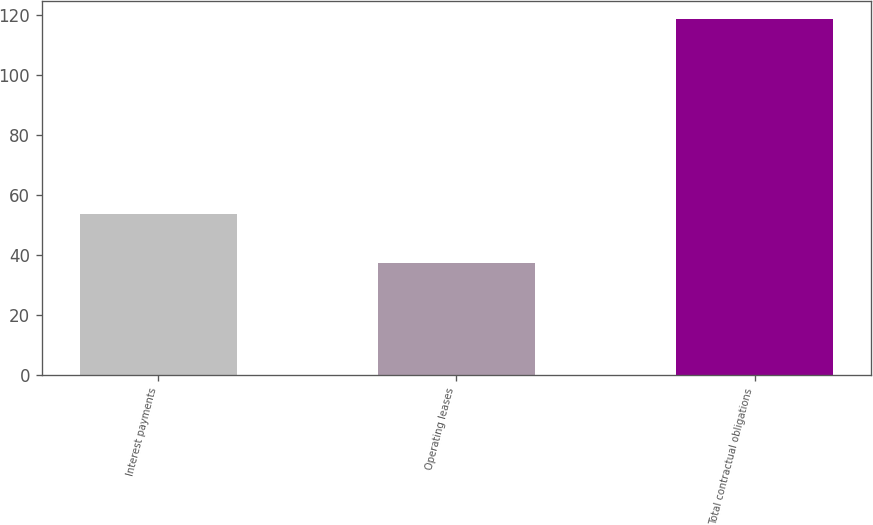Convert chart to OTSL. <chart><loc_0><loc_0><loc_500><loc_500><bar_chart><fcel>Interest payments<fcel>Operating leases<fcel>Total contractual obligations<nl><fcel>53.7<fcel>37.3<fcel>118.8<nl></chart> 